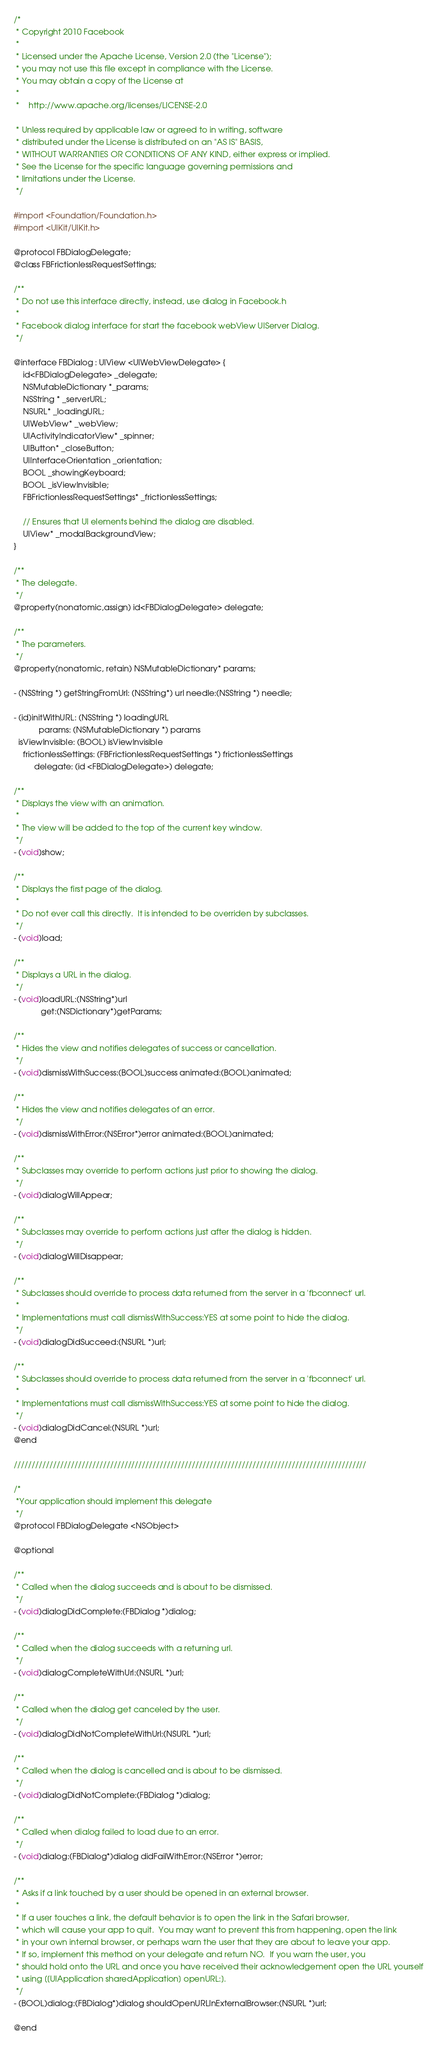<code> <loc_0><loc_0><loc_500><loc_500><_C_>/*
 * Copyright 2010 Facebook
 *
 * Licensed under the Apache License, Version 2.0 (the "License");
 * you may not use this file except in compliance with the License.
 * You may obtain a copy of the License at
 *
 *    http://www.apache.org/licenses/LICENSE-2.0
 
 * Unless required by applicable law or agreed to in writing, software
 * distributed under the License is distributed on an "AS IS" BASIS,
 * WITHOUT WARRANTIES OR CONDITIONS OF ANY KIND, either express or implied.
 * See the License for the specific language governing permissions and
 * limitations under the License.
 */

#import <Foundation/Foundation.h>
#import <UIKit/UIKit.h>

@protocol FBDialogDelegate;
@class FBFrictionlessRequestSettings;

/**
 * Do not use this interface directly, instead, use dialog in Facebook.h
 *
 * Facebook dialog interface for start the facebook webView UIServer Dialog.
 */

@interface FBDialog : UIView <UIWebViewDelegate> {
    id<FBDialogDelegate> _delegate;
    NSMutableDictionary *_params;
    NSString * _serverURL;
    NSURL* _loadingURL;
    UIWebView* _webView;
    UIActivityIndicatorView* _spinner;
    UIButton* _closeButton;
    UIInterfaceOrientation _orientation;
    BOOL _showingKeyboard;
    BOOL _isViewInvisible;
    FBFrictionlessRequestSettings* _frictionlessSettings;
    
    // Ensures that UI elements behind the dialog are disabled.
    UIView* _modalBackgroundView;
}

/**
 * The delegate.
 */
@property(nonatomic,assign) id<FBDialogDelegate> delegate;

/**
 * The parameters.
 */
@property(nonatomic, retain) NSMutableDictionary* params;

- (NSString *) getStringFromUrl: (NSString*) url needle:(NSString *) needle;

- (id)initWithURL: (NSString *) loadingURL
           params: (NSMutableDictionary *) params
  isViewInvisible: (BOOL) isViewInvisible
    frictionlessSettings: (FBFrictionlessRequestSettings *) frictionlessSettings
         delegate: (id <FBDialogDelegate>) delegate;

/**
 * Displays the view with an animation.
 *
 * The view will be added to the top of the current key window.
 */
- (void)show;

/**
 * Displays the first page of the dialog.
 *
 * Do not ever call this directly.  It is intended to be overriden by subclasses.
 */
- (void)load;

/**
 * Displays a URL in the dialog.
 */
- (void)loadURL:(NSString*)url
            get:(NSDictionary*)getParams;

/**
 * Hides the view and notifies delegates of success or cancellation.
 */
- (void)dismissWithSuccess:(BOOL)success animated:(BOOL)animated;

/**
 * Hides the view and notifies delegates of an error.
 */
- (void)dismissWithError:(NSError*)error animated:(BOOL)animated;

/**
 * Subclasses may override to perform actions just prior to showing the dialog.
 */
- (void)dialogWillAppear;

/**
 * Subclasses may override to perform actions just after the dialog is hidden.
 */
- (void)dialogWillDisappear;

/**
 * Subclasses should override to process data returned from the server in a 'fbconnect' url.
 *
 * Implementations must call dismissWithSuccess:YES at some point to hide the dialog.
 */
- (void)dialogDidSucceed:(NSURL *)url;

/**
 * Subclasses should override to process data returned from the server in a 'fbconnect' url.
 *
 * Implementations must call dismissWithSuccess:YES at some point to hide the dialog.
 */
- (void)dialogDidCancel:(NSURL *)url;
@end

///////////////////////////////////////////////////////////////////////////////////////////////////

/*
 *Your application should implement this delegate
 */
@protocol FBDialogDelegate <NSObject>

@optional

/**
 * Called when the dialog succeeds and is about to be dismissed.
 */
- (void)dialogDidComplete:(FBDialog *)dialog;

/**
 * Called when the dialog succeeds with a returning url.
 */
- (void)dialogCompleteWithUrl:(NSURL *)url;

/**
 * Called when the dialog get canceled by the user.
 */
- (void)dialogDidNotCompleteWithUrl:(NSURL *)url;

/**
 * Called when the dialog is cancelled and is about to be dismissed.
 */
- (void)dialogDidNotComplete:(FBDialog *)dialog;

/**
 * Called when dialog failed to load due to an error.
 */
- (void)dialog:(FBDialog*)dialog didFailWithError:(NSError *)error;

/**
 * Asks if a link touched by a user should be opened in an external browser.
 *
 * If a user touches a link, the default behavior is to open the link in the Safari browser,
 * which will cause your app to quit.  You may want to prevent this from happening, open the link
 * in your own internal browser, or perhaps warn the user that they are about to leave your app.
 * If so, implement this method on your delegate and return NO.  If you warn the user, you
 * should hold onto the URL and once you have received their acknowledgement open the URL yourself
 * using [[UIApplication sharedApplication] openURL:].
 */
- (BOOL)dialog:(FBDialog*)dialog shouldOpenURLInExternalBrowser:(NSURL *)url;

@end
</code> 